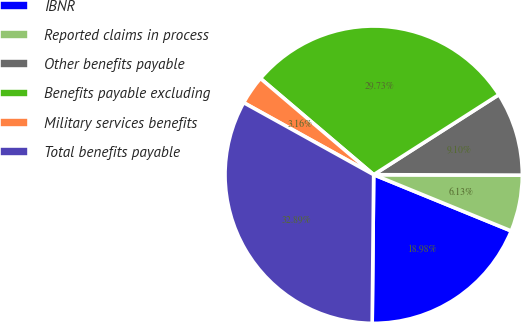<chart> <loc_0><loc_0><loc_500><loc_500><pie_chart><fcel>IBNR<fcel>Reported claims in process<fcel>Other benefits payable<fcel>Benefits payable excluding<fcel>Military services benefits<fcel>Total benefits payable<nl><fcel>18.98%<fcel>6.13%<fcel>9.1%<fcel>29.73%<fcel>3.16%<fcel>32.89%<nl></chart> 